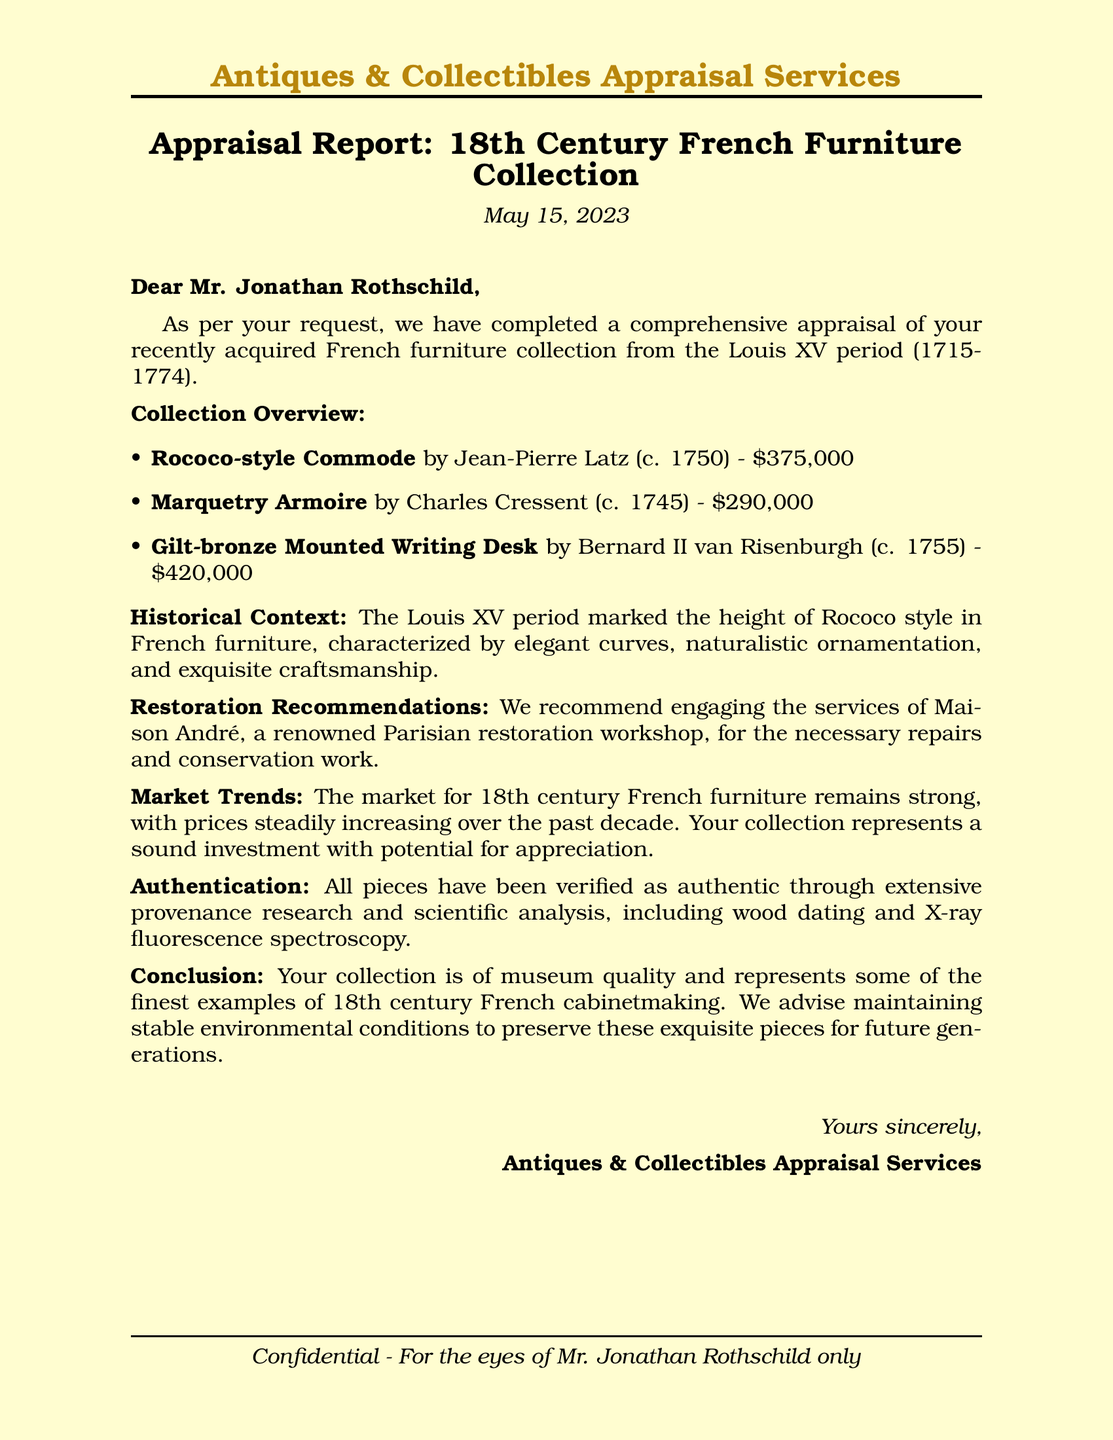What is the date of the appraisal report? The date is explicitly mentioned at the beginning of the document, which is May 15, 2023.
Answer: May 15, 2023 Who is the author of the Rococo-style Commode? The author is noted in the description of the commode, which is Jean-Pierre Latz.
Answer: Jean-Pierre Latz What is the value of the Marquetry Armoire? The value is listed in the collection overview as $290,000.
Answer: $290,000 What restoration workshop is recommended? The recommended workshop is stated in the restoration recommendations section as Maison André.
Answer: Maison André What style is characterized by elegant curves and naturalistic ornamentation? This style refers to the Rococo style, which is mentioned in the historical context.
Answer: Rococo What period does the furniture collection belong to? The document specifies the collection belongs to the Louis XV period (1715-1774).
Answer: Louis XV period How much is the Gilt-bronze Mounted Writing Desk worth? The worth of the desk is included in the collection overview, which states $420,000.
Answer: $420,000 What type of authentication methods were used for the pieces? The authentication methods mentioned include wood dating and X-ray fluorescence spectroscopy.
Answer: Wood dating and X-ray fluorescence spectroscopy What is the market trend for 18th century French furniture? The document states that the market trend is strong with prices steadily increasing over the past decade.
Answer: Strong, steadily increasing 